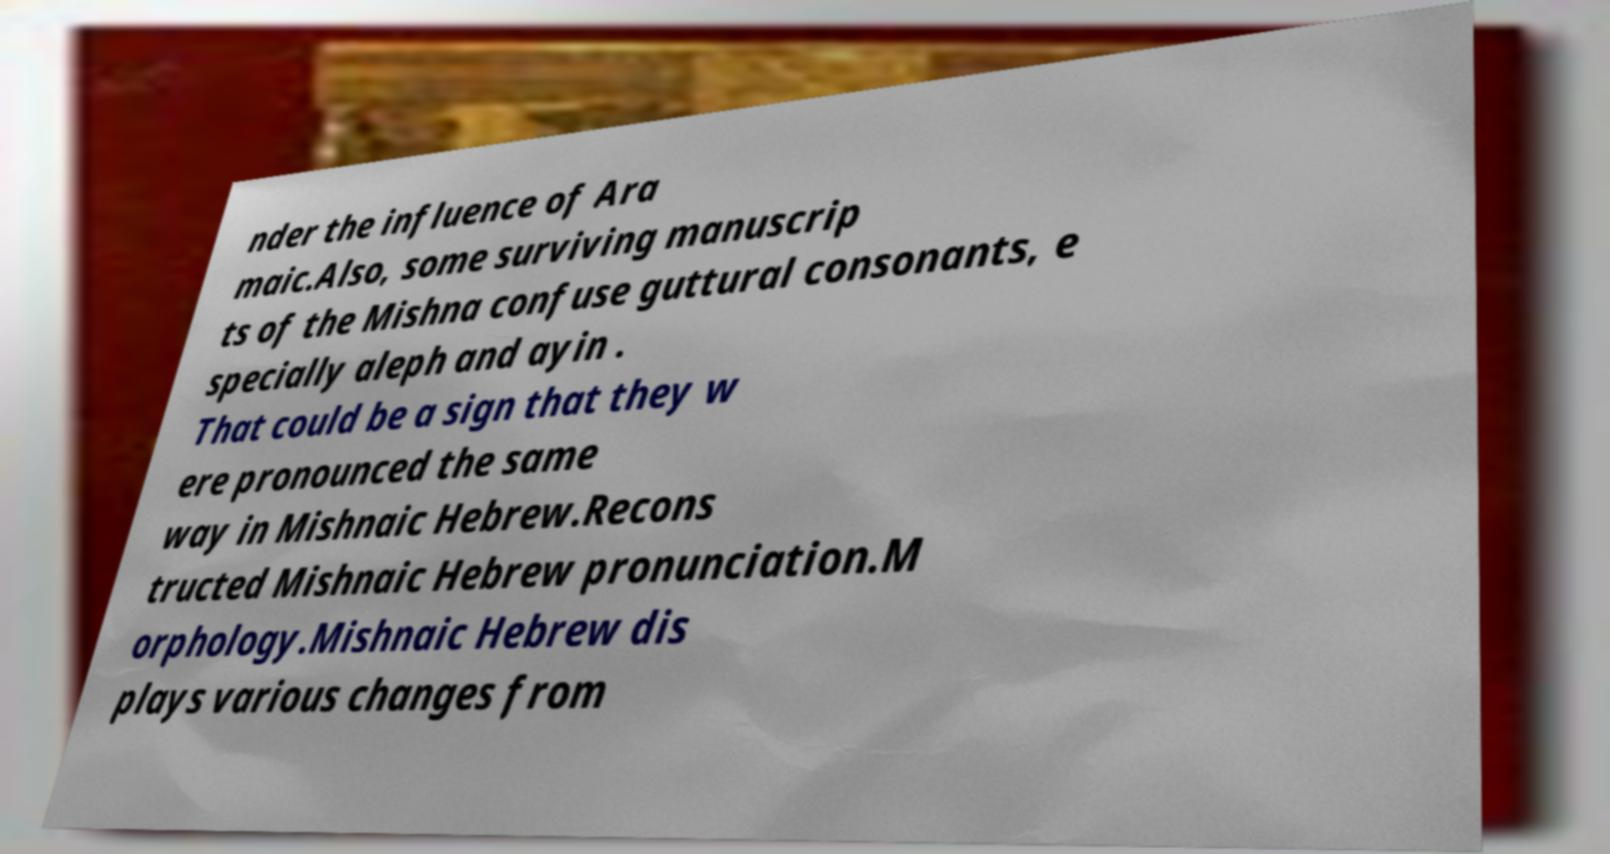I need the written content from this picture converted into text. Can you do that? nder the influence of Ara maic.Also, some surviving manuscrip ts of the Mishna confuse guttural consonants, e specially aleph and ayin . That could be a sign that they w ere pronounced the same way in Mishnaic Hebrew.Recons tructed Mishnaic Hebrew pronunciation.M orphology.Mishnaic Hebrew dis plays various changes from 